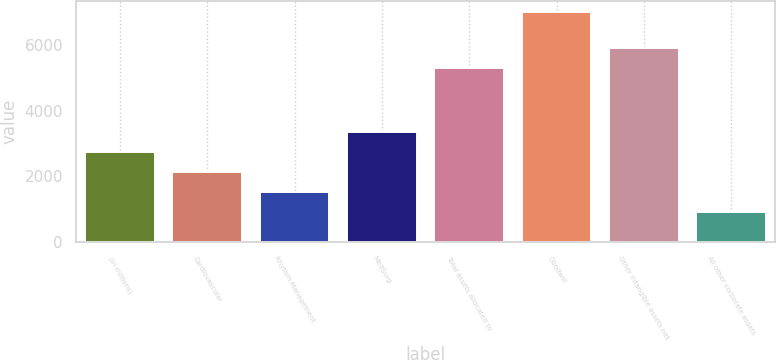Convert chart to OTSL. <chart><loc_0><loc_0><loc_500><loc_500><bar_chart><fcel>(in millions)<fcel>Cardiovascular<fcel>Rhythm Management<fcel>MedSurg<fcel>Total assets allocated to<fcel>Goodwill<fcel>Other intangible assets net<fcel>All other corporate assets<nl><fcel>2732.9<fcel>2123.6<fcel>1514.3<fcel>3342.2<fcel>5302<fcel>6998<fcel>5911.3<fcel>905<nl></chart> 